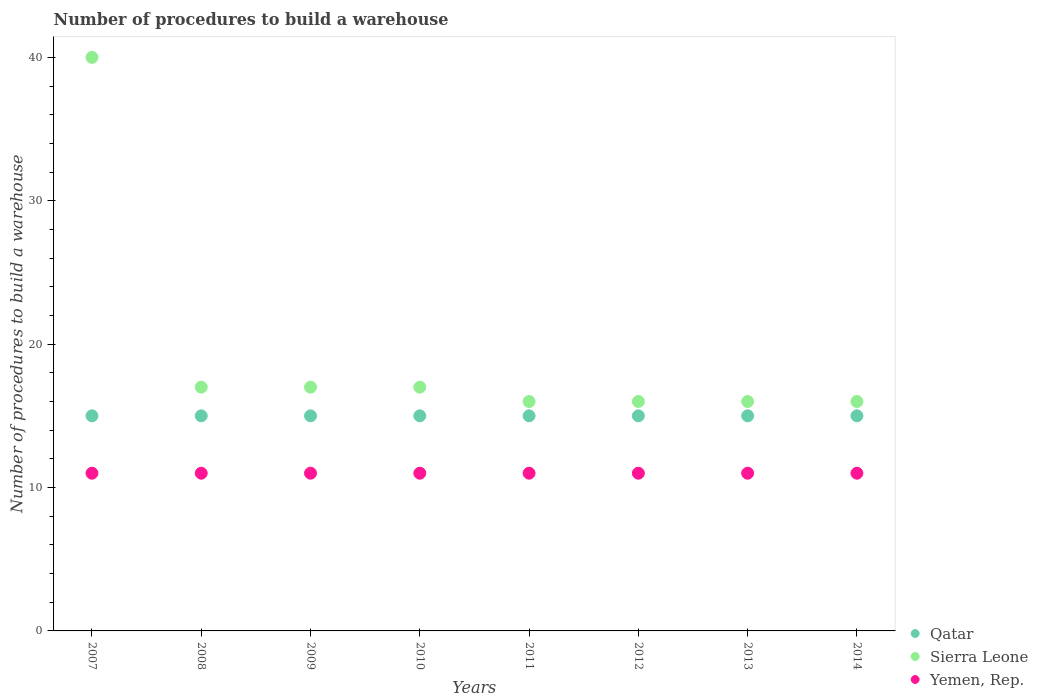Across all years, what is the maximum number of procedures to build a warehouse in in Sierra Leone?
Your answer should be compact. 40. Across all years, what is the minimum number of procedures to build a warehouse in in Sierra Leone?
Give a very brief answer. 16. In which year was the number of procedures to build a warehouse in in Yemen, Rep. minimum?
Offer a very short reply. 2007. What is the total number of procedures to build a warehouse in in Yemen, Rep. in the graph?
Give a very brief answer. 88. What is the difference between the number of procedures to build a warehouse in in Sierra Leone in 2009 and that in 2011?
Make the answer very short. 1. In how many years, is the number of procedures to build a warehouse in in Qatar greater than 30?
Provide a short and direct response. 0. Is the number of procedures to build a warehouse in in Qatar in 2009 less than that in 2012?
Keep it short and to the point. No. Is the difference between the number of procedures to build a warehouse in in Qatar in 2010 and 2011 greater than the difference between the number of procedures to build a warehouse in in Yemen, Rep. in 2010 and 2011?
Keep it short and to the point. No. What is the difference between the highest and the second highest number of procedures to build a warehouse in in Sierra Leone?
Ensure brevity in your answer.  23. What is the difference between the highest and the lowest number of procedures to build a warehouse in in Qatar?
Your response must be concise. 0. Is the sum of the number of procedures to build a warehouse in in Qatar in 2008 and 2010 greater than the maximum number of procedures to build a warehouse in in Yemen, Rep. across all years?
Your response must be concise. Yes. Is the number of procedures to build a warehouse in in Sierra Leone strictly greater than the number of procedures to build a warehouse in in Yemen, Rep. over the years?
Provide a succinct answer. Yes. Is the number of procedures to build a warehouse in in Yemen, Rep. strictly less than the number of procedures to build a warehouse in in Sierra Leone over the years?
Offer a very short reply. Yes. How many years are there in the graph?
Your answer should be very brief. 8. What is the difference between two consecutive major ticks on the Y-axis?
Your answer should be very brief. 10. Does the graph contain any zero values?
Provide a succinct answer. No. How are the legend labels stacked?
Your answer should be compact. Vertical. What is the title of the graph?
Your answer should be very brief. Number of procedures to build a warehouse. Does "Azerbaijan" appear as one of the legend labels in the graph?
Give a very brief answer. No. What is the label or title of the X-axis?
Offer a terse response. Years. What is the label or title of the Y-axis?
Your answer should be very brief. Number of procedures to build a warehouse. What is the Number of procedures to build a warehouse in Qatar in 2007?
Offer a very short reply. 15. What is the Number of procedures to build a warehouse of Qatar in 2008?
Keep it short and to the point. 15. What is the Number of procedures to build a warehouse of Yemen, Rep. in 2008?
Your answer should be compact. 11. What is the Number of procedures to build a warehouse of Qatar in 2010?
Offer a very short reply. 15. What is the Number of procedures to build a warehouse in Sierra Leone in 2010?
Your answer should be very brief. 17. What is the Number of procedures to build a warehouse of Qatar in 2011?
Offer a terse response. 15. What is the Number of procedures to build a warehouse in Yemen, Rep. in 2011?
Offer a terse response. 11. What is the Number of procedures to build a warehouse of Yemen, Rep. in 2012?
Offer a terse response. 11. What is the Number of procedures to build a warehouse in Qatar in 2013?
Offer a very short reply. 15. What is the Number of procedures to build a warehouse in Sierra Leone in 2013?
Offer a terse response. 16. What is the Number of procedures to build a warehouse in Sierra Leone in 2014?
Give a very brief answer. 16. Across all years, what is the maximum Number of procedures to build a warehouse of Qatar?
Keep it short and to the point. 15. Across all years, what is the maximum Number of procedures to build a warehouse of Yemen, Rep.?
Provide a short and direct response. 11. Across all years, what is the minimum Number of procedures to build a warehouse of Qatar?
Offer a terse response. 15. Across all years, what is the minimum Number of procedures to build a warehouse in Sierra Leone?
Give a very brief answer. 16. Across all years, what is the minimum Number of procedures to build a warehouse in Yemen, Rep.?
Your answer should be very brief. 11. What is the total Number of procedures to build a warehouse in Qatar in the graph?
Give a very brief answer. 120. What is the total Number of procedures to build a warehouse of Sierra Leone in the graph?
Offer a very short reply. 155. What is the total Number of procedures to build a warehouse of Yemen, Rep. in the graph?
Ensure brevity in your answer.  88. What is the difference between the Number of procedures to build a warehouse of Sierra Leone in 2007 and that in 2008?
Offer a very short reply. 23. What is the difference between the Number of procedures to build a warehouse in Qatar in 2007 and that in 2009?
Offer a very short reply. 0. What is the difference between the Number of procedures to build a warehouse of Qatar in 2007 and that in 2010?
Offer a terse response. 0. What is the difference between the Number of procedures to build a warehouse in Sierra Leone in 2007 and that in 2010?
Give a very brief answer. 23. What is the difference between the Number of procedures to build a warehouse of Yemen, Rep. in 2007 and that in 2010?
Make the answer very short. 0. What is the difference between the Number of procedures to build a warehouse in Sierra Leone in 2007 and that in 2011?
Offer a very short reply. 24. What is the difference between the Number of procedures to build a warehouse of Qatar in 2007 and that in 2012?
Provide a succinct answer. 0. What is the difference between the Number of procedures to build a warehouse in Sierra Leone in 2007 and that in 2012?
Ensure brevity in your answer.  24. What is the difference between the Number of procedures to build a warehouse of Yemen, Rep. in 2007 and that in 2012?
Give a very brief answer. 0. What is the difference between the Number of procedures to build a warehouse in Sierra Leone in 2007 and that in 2013?
Offer a terse response. 24. What is the difference between the Number of procedures to build a warehouse in Yemen, Rep. in 2007 and that in 2013?
Your answer should be very brief. 0. What is the difference between the Number of procedures to build a warehouse in Qatar in 2007 and that in 2014?
Keep it short and to the point. 0. What is the difference between the Number of procedures to build a warehouse of Yemen, Rep. in 2007 and that in 2014?
Provide a short and direct response. 0. What is the difference between the Number of procedures to build a warehouse in Qatar in 2008 and that in 2009?
Offer a very short reply. 0. What is the difference between the Number of procedures to build a warehouse of Yemen, Rep. in 2008 and that in 2009?
Keep it short and to the point. 0. What is the difference between the Number of procedures to build a warehouse in Sierra Leone in 2008 and that in 2010?
Provide a short and direct response. 0. What is the difference between the Number of procedures to build a warehouse of Yemen, Rep. in 2008 and that in 2010?
Provide a short and direct response. 0. What is the difference between the Number of procedures to build a warehouse of Sierra Leone in 2008 and that in 2011?
Provide a succinct answer. 1. What is the difference between the Number of procedures to build a warehouse in Qatar in 2008 and that in 2012?
Provide a succinct answer. 0. What is the difference between the Number of procedures to build a warehouse in Yemen, Rep. in 2008 and that in 2012?
Offer a terse response. 0. What is the difference between the Number of procedures to build a warehouse in Sierra Leone in 2008 and that in 2014?
Make the answer very short. 1. What is the difference between the Number of procedures to build a warehouse in Yemen, Rep. in 2009 and that in 2010?
Offer a very short reply. 0. What is the difference between the Number of procedures to build a warehouse of Qatar in 2009 and that in 2011?
Give a very brief answer. 0. What is the difference between the Number of procedures to build a warehouse of Sierra Leone in 2009 and that in 2011?
Provide a short and direct response. 1. What is the difference between the Number of procedures to build a warehouse in Sierra Leone in 2009 and that in 2012?
Give a very brief answer. 1. What is the difference between the Number of procedures to build a warehouse of Yemen, Rep. in 2009 and that in 2012?
Offer a terse response. 0. What is the difference between the Number of procedures to build a warehouse of Sierra Leone in 2009 and that in 2013?
Offer a terse response. 1. What is the difference between the Number of procedures to build a warehouse in Yemen, Rep. in 2009 and that in 2013?
Give a very brief answer. 0. What is the difference between the Number of procedures to build a warehouse in Qatar in 2009 and that in 2014?
Offer a very short reply. 0. What is the difference between the Number of procedures to build a warehouse in Yemen, Rep. in 2009 and that in 2014?
Offer a terse response. 0. What is the difference between the Number of procedures to build a warehouse of Yemen, Rep. in 2010 and that in 2012?
Ensure brevity in your answer.  0. What is the difference between the Number of procedures to build a warehouse in Qatar in 2010 and that in 2013?
Give a very brief answer. 0. What is the difference between the Number of procedures to build a warehouse in Yemen, Rep. in 2010 and that in 2014?
Your response must be concise. 0. What is the difference between the Number of procedures to build a warehouse of Qatar in 2011 and that in 2012?
Provide a short and direct response. 0. What is the difference between the Number of procedures to build a warehouse in Yemen, Rep. in 2011 and that in 2012?
Give a very brief answer. 0. What is the difference between the Number of procedures to build a warehouse of Sierra Leone in 2011 and that in 2013?
Make the answer very short. 0. What is the difference between the Number of procedures to build a warehouse of Yemen, Rep. in 2011 and that in 2013?
Your response must be concise. 0. What is the difference between the Number of procedures to build a warehouse in Qatar in 2011 and that in 2014?
Make the answer very short. 0. What is the difference between the Number of procedures to build a warehouse of Sierra Leone in 2011 and that in 2014?
Provide a succinct answer. 0. What is the difference between the Number of procedures to build a warehouse of Qatar in 2012 and that in 2013?
Provide a short and direct response. 0. What is the difference between the Number of procedures to build a warehouse in Qatar in 2012 and that in 2014?
Ensure brevity in your answer.  0. What is the difference between the Number of procedures to build a warehouse of Qatar in 2013 and that in 2014?
Your answer should be compact. 0. What is the difference between the Number of procedures to build a warehouse in Yemen, Rep. in 2013 and that in 2014?
Your answer should be compact. 0. What is the difference between the Number of procedures to build a warehouse of Qatar in 2007 and the Number of procedures to build a warehouse of Yemen, Rep. in 2008?
Provide a short and direct response. 4. What is the difference between the Number of procedures to build a warehouse of Sierra Leone in 2007 and the Number of procedures to build a warehouse of Yemen, Rep. in 2008?
Provide a succinct answer. 29. What is the difference between the Number of procedures to build a warehouse of Sierra Leone in 2007 and the Number of procedures to build a warehouse of Yemen, Rep. in 2009?
Keep it short and to the point. 29. What is the difference between the Number of procedures to build a warehouse of Qatar in 2007 and the Number of procedures to build a warehouse of Sierra Leone in 2010?
Your answer should be compact. -2. What is the difference between the Number of procedures to build a warehouse in Qatar in 2007 and the Number of procedures to build a warehouse in Yemen, Rep. in 2010?
Make the answer very short. 4. What is the difference between the Number of procedures to build a warehouse of Sierra Leone in 2007 and the Number of procedures to build a warehouse of Yemen, Rep. in 2010?
Provide a short and direct response. 29. What is the difference between the Number of procedures to build a warehouse of Qatar in 2007 and the Number of procedures to build a warehouse of Sierra Leone in 2011?
Provide a succinct answer. -1. What is the difference between the Number of procedures to build a warehouse of Qatar in 2007 and the Number of procedures to build a warehouse of Yemen, Rep. in 2011?
Your response must be concise. 4. What is the difference between the Number of procedures to build a warehouse in Sierra Leone in 2007 and the Number of procedures to build a warehouse in Yemen, Rep. in 2011?
Give a very brief answer. 29. What is the difference between the Number of procedures to build a warehouse of Qatar in 2007 and the Number of procedures to build a warehouse of Sierra Leone in 2012?
Your answer should be very brief. -1. What is the difference between the Number of procedures to build a warehouse in Sierra Leone in 2007 and the Number of procedures to build a warehouse in Yemen, Rep. in 2012?
Offer a terse response. 29. What is the difference between the Number of procedures to build a warehouse of Qatar in 2007 and the Number of procedures to build a warehouse of Yemen, Rep. in 2013?
Offer a terse response. 4. What is the difference between the Number of procedures to build a warehouse in Sierra Leone in 2007 and the Number of procedures to build a warehouse in Yemen, Rep. in 2013?
Give a very brief answer. 29. What is the difference between the Number of procedures to build a warehouse in Qatar in 2007 and the Number of procedures to build a warehouse in Yemen, Rep. in 2014?
Offer a terse response. 4. What is the difference between the Number of procedures to build a warehouse of Sierra Leone in 2007 and the Number of procedures to build a warehouse of Yemen, Rep. in 2014?
Give a very brief answer. 29. What is the difference between the Number of procedures to build a warehouse of Qatar in 2008 and the Number of procedures to build a warehouse of Sierra Leone in 2009?
Provide a short and direct response. -2. What is the difference between the Number of procedures to build a warehouse of Qatar in 2008 and the Number of procedures to build a warehouse of Yemen, Rep. in 2009?
Your answer should be compact. 4. What is the difference between the Number of procedures to build a warehouse of Sierra Leone in 2008 and the Number of procedures to build a warehouse of Yemen, Rep. in 2009?
Provide a succinct answer. 6. What is the difference between the Number of procedures to build a warehouse of Qatar in 2008 and the Number of procedures to build a warehouse of Sierra Leone in 2010?
Your answer should be compact. -2. What is the difference between the Number of procedures to build a warehouse in Qatar in 2008 and the Number of procedures to build a warehouse in Yemen, Rep. in 2010?
Make the answer very short. 4. What is the difference between the Number of procedures to build a warehouse in Qatar in 2008 and the Number of procedures to build a warehouse in Yemen, Rep. in 2011?
Provide a succinct answer. 4. What is the difference between the Number of procedures to build a warehouse in Qatar in 2008 and the Number of procedures to build a warehouse in Sierra Leone in 2012?
Ensure brevity in your answer.  -1. What is the difference between the Number of procedures to build a warehouse of Sierra Leone in 2008 and the Number of procedures to build a warehouse of Yemen, Rep. in 2012?
Your answer should be very brief. 6. What is the difference between the Number of procedures to build a warehouse in Sierra Leone in 2008 and the Number of procedures to build a warehouse in Yemen, Rep. in 2013?
Your answer should be very brief. 6. What is the difference between the Number of procedures to build a warehouse in Qatar in 2008 and the Number of procedures to build a warehouse in Sierra Leone in 2014?
Give a very brief answer. -1. What is the difference between the Number of procedures to build a warehouse in Qatar in 2008 and the Number of procedures to build a warehouse in Yemen, Rep. in 2014?
Provide a succinct answer. 4. What is the difference between the Number of procedures to build a warehouse in Sierra Leone in 2008 and the Number of procedures to build a warehouse in Yemen, Rep. in 2014?
Provide a short and direct response. 6. What is the difference between the Number of procedures to build a warehouse in Qatar in 2009 and the Number of procedures to build a warehouse in Sierra Leone in 2010?
Provide a short and direct response. -2. What is the difference between the Number of procedures to build a warehouse in Qatar in 2009 and the Number of procedures to build a warehouse in Yemen, Rep. in 2010?
Your answer should be compact. 4. What is the difference between the Number of procedures to build a warehouse in Qatar in 2009 and the Number of procedures to build a warehouse in Sierra Leone in 2011?
Give a very brief answer. -1. What is the difference between the Number of procedures to build a warehouse in Qatar in 2009 and the Number of procedures to build a warehouse in Yemen, Rep. in 2011?
Give a very brief answer. 4. What is the difference between the Number of procedures to build a warehouse of Sierra Leone in 2009 and the Number of procedures to build a warehouse of Yemen, Rep. in 2013?
Offer a terse response. 6. What is the difference between the Number of procedures to build a warehouse in Qatar in 2009 and the Number of procedures to build a warehouse in Yemen, Rep. in 2014?
Provide a succinct answer. 4. What is the difference between the Number of procedures to build a warehouse of Sierra Leone in 2010 and the Number of procedures to build a warehouse of Yemen, Rep. in 2013?
Your answer should be compact. 6. What is the difference between the Number of procedures to build a warehouse in Qatar in 2011 and the Number of procedures to build a warehouse in Sierra Leone in 2012?
Your answer should be very brief. -1. What is the difference between the Number of procedures to build a warehouse of Qatar in 2011 and the Number of procedures to build a warehouse of Yemen, Rep. in 2012?
Give a very brief answer. 4. What is the difference between the Number of procedures to build a warehouse of Qatar in 2011 and the Number of procedures to build a warehouse of Yemen, Rep. in 2014?
Make the answer very short. 4. What is the difference between the Number of procedures to build a warehouse of Qatar in 2012 and the Number of procedures to build a warehouse of Yemen, Rep. in 2013?
Make the answer very short. 4. What is the difference between the Number of procedures to build a warehouse of Sierra Leone in 2012 and the Number of procedures to build a warehouse of Yemen, Rep. in 2013?
Ensure brevity in your answer.  5. What is the difference between the Number of procedures to build a warehouse in Qatar in 2012 and the Number of procedures to build a warehouse in Sierra Leone in 2014?
Ensure brevity in your answer.  -1. What is the difference between the Number of procedures to build a warehouse of Sierra Leone in 2012 and the Number of procedures to build a warehouse of Yemen, Rep. in 2014?
Make the answer very short. 5. What is the average Number of procedures to build a warehouse in Sierra Leone per year?
Offer a very short reply. 19.38. In the year 2007, what is the difference between the Number of procedures to build a warehouse of Qatar and Number of procedures to build a warehouse of Sierra Leone?
Make the answer very short. -25. In the year 2007, what is the difference between the Number of procedures to build a warehouse in Qatar and Number of procedures to build a warehouse in Yemen, Rep.?
Ensure brevity in your answer.  4. In the year 2008, what is the difference between the Number of procedures to build a warehouse in Qatar and Number of procedures to build a warehouse in Sierra Leone?
Give a very brief answer. -2. In the year 2008, what is the difference between the Number of procedures to build a warehouse of Sierra Leone and Number of procedures to build a warehouse of Yemen, Rep.?
Ensure brevity in your answer.  6. In the year 2009, what is the difference between the Number of procedures to build a warehouse of Qatar and Number of procedures to build a warehouse of Yemen, Rep.?
Keep it short and to the point. 4. In the year 2009, what is the difference between the Number of procedures to build a warehouse of Sierra Leone and Number of procedures to build a warehouse of Yemen, Rep.?
Your answer should be very brief. 6. In the year 2010, what is the difference between the Number of procedures to build a warehouse of Qatar and Number of procedures to build a warehouse of Sierra Leone?
Make the answer very short. -2. In the year 2010, what is the difference between the Number of procedures to build a warehouse of Qatar and Number of procedures to build a warehouse of Yemen, Rep.?
Offer a very short reply. 4. In the year 2010, what is the difference between the Number of procedures to build a warehouse of Sierra Leone and Number of procedures to build a warehouse of Yemen, Rep.?
Your answer should be very brief. 6. In the year 2011, what is the difference between the Number of procedures to build a warehouse of Qatar and Number of procedures to build a warehouse of Yemen, Rep.?
Provide a succinct answer. 4. In the year 2012, what is the difference between the Number of procedures to build a warehouse of Qatar and Number of procedures to build a warehouse of Yemen, Rep.?
Keep it short and to the point. 4. In the year 2013, what is the difference between the Number of procedures to build a warehouse of Qatar and Number of procedures to build a warehouse of Sierra Leone?
Make the answer very short. -1. In the year 2013, what is the difference between the Number of procedures to build a warehouse of Sierra Leone and Number of procedures to build a warehouse of Yemen, Rep.?
Offer a very short reply. 5. What is the ratio of the Number of procedures to build a warehouse in Sierra Leone in 2007 to that in 2008?
Your answer should be compact. 2.35. What is the ratio of the Number of procedures to build a warehouse of Yemen, Rep. in 2007 to that in 2008?
Ensure brevity in your answer.  1. What is the ratio of the Number of procedures to build a warehouse in Sierra Leone in 2007 to that in 2009?
Provide a short and direct response. 2.35. What is the ratio of the Number of procedures to build a warehouse in Sierra Leone in 2007 to that in 2010?
Give a very brief answer. 2.35. What is the ratio of the Number of procedures to build a warehouse of Sierra Leone in 2007 to that in 2011?
Provide a succinct answer. 2.5. What is the ratio of the Number of procedures to build a warehouse in Qatar in 2007 to that in 2013?
Make the answer very short. 1. What is the ratio of the Number of procedures to build a warehouse of Sierra Leone in 2007 to that in 2013?
Your response must be concise. 2.5. What is the ratio of the Number of procedures to build a warehouse in Yemen, Rep. in 2007 to that in 2013?
Provide a short and direct response. 1. What is the ratio of the Number of procedures to build a warehouse in Sierra Leone in 2007 to that in 2014?
Make the answer very short. 2.5. What is the ratio of the Number of procedures to build a warehouse of Yemen, Rep. in 2007 to that in 2014?
Offer a very short reply. 1. What is the ratio of the Number of procedures to build a warehouse in Sierra Leone in 2008 to that in 2009?
Make the answer very short. 1. What is the ratio of the Number of procedures to build a warehouse of Yemen, Rep. in 2008 to that in 2010?
Provide a short and direct response. 1. What is the ratio of the Number of procedures to build a warehouse of Qatar in 2008 to that in 2011?
Provide a short and direct response. 1. What is the ratio of the Number of procedures to build a warehouse in Qatar in 2008 to that in 2012?
Offer a terse response. 1. What is the ratio of the Number of procedures to build a warehouse of Sierra Leone in 2008 to that in 2012?
Offer a very short reply. 1.06. What is the ratio of the Number of procedures to build a warehouse in Yemen, Rep. in 2008 to that in 2012?
Provide a succinct answer. 1. What is the ratio of the Number of procedures to build a warehouse of Qatar in 2008 to that in 2014?
Your response must be concise. 1. What is the ratio of the Number of procedures to build a warehouse in Sierra Leone in 2008 to that in 2014?
Your answer should be compact. 1.06. What is the ratio of the Number of procedures to build a warehouse of Sierra Leone in 2009 to that in 2010?
Give a very brief answer. 1. What is the ratio of the Number of procedures to build a warehouse of Qatar in 2009 to that in 2013?
Make the answer very short. 1. What is the ratio of the Number of procedures to build a warehouse in Qatar in 2009 to that in 2014?
Make the answer very short. 1. What is the ratio of the Number of procedures to build a warehouse of Sierra Leone in 2009 to that in 2014?
Give a very brief answer. 1.06. What is the ratio of the Number of procedures to build a warehouse in Yemen, Rep. in 2009 to that in 2014?
Your answer should be very brief. 1. What is the ratio of the Number of procedures to build a warehouse of Qatar in 2010 to that in 2011?
Provide a short and direct response. 1. What is the ratio of the Number of procedures to build a warehouse of Qatar in 2010 to that in 2012?
Your response must be concise. 1. What is the ratio of the Number of procedures to build a warehouse of Sierra Leone in 2010 to that in 2013?
Provide a short and direct response. 1.06. What is the ratio of the Number of procedures to build a warehouse of Yemen, Rep. in 2010 to that in 2013?
Your response must be concise. 1. What is the ratio of the Number of procedures to build a warehouse of Sierra Leone in 2010 to that in 2014?
Provide a short and direct response. 1.06. What is the ratio of the Number of procedures to build a warehouse of Yemen, Rep. in 2010 to that in 2014?
Keep it short and to the point. 1. What is the ratio of the Number of procedures to build a warehouse of Yemen, Rep. in 2011 to that in 2012?
Your answer should be compact. 1. What is the ratio of the Number of procedures to build a warehouse in Qatar in 2011 to that in 2013?
Your answer should be compact. 1. What is the ratio of the Number of procedures to build a warehouse in Sierra Leone in 2011 to that in 2013?
Make the answer very short. 1. What is the ratio of the Number of procedures to build a warehouse in Sierra Leone in 2011 to that in 2014?
Provide a short and direct response. 1. What is the ratio of the Number of procedures to build a warehouse in Yemen, Rep. in 2011 to that in 2014?
Give a very brief answer. 1. What is the ratio of the Number of procedures to build a warehouse in Yemen, Rep. in 2012 to that in 2014?
Offer a very short reply. 1. What is the ratio of the Number of procedures to build a warehouse of Qatar in 2013 to that in 2014?
Provide a succinct answer. 1. What is the ratio of the Number of procedures to build a warehouse of Yemen, Rep. in 2013 to that in 2014?
Offer a terse response. 1. What is the difference between the highest and the second highest Number of procedures to build a warehouse of Qatar?
Provide a short and direct response. 0. What is the difference between the highest and the second highest Number of procedures to build a warehouse in Sierra Leone?
Provide a short and direct response. 23. 